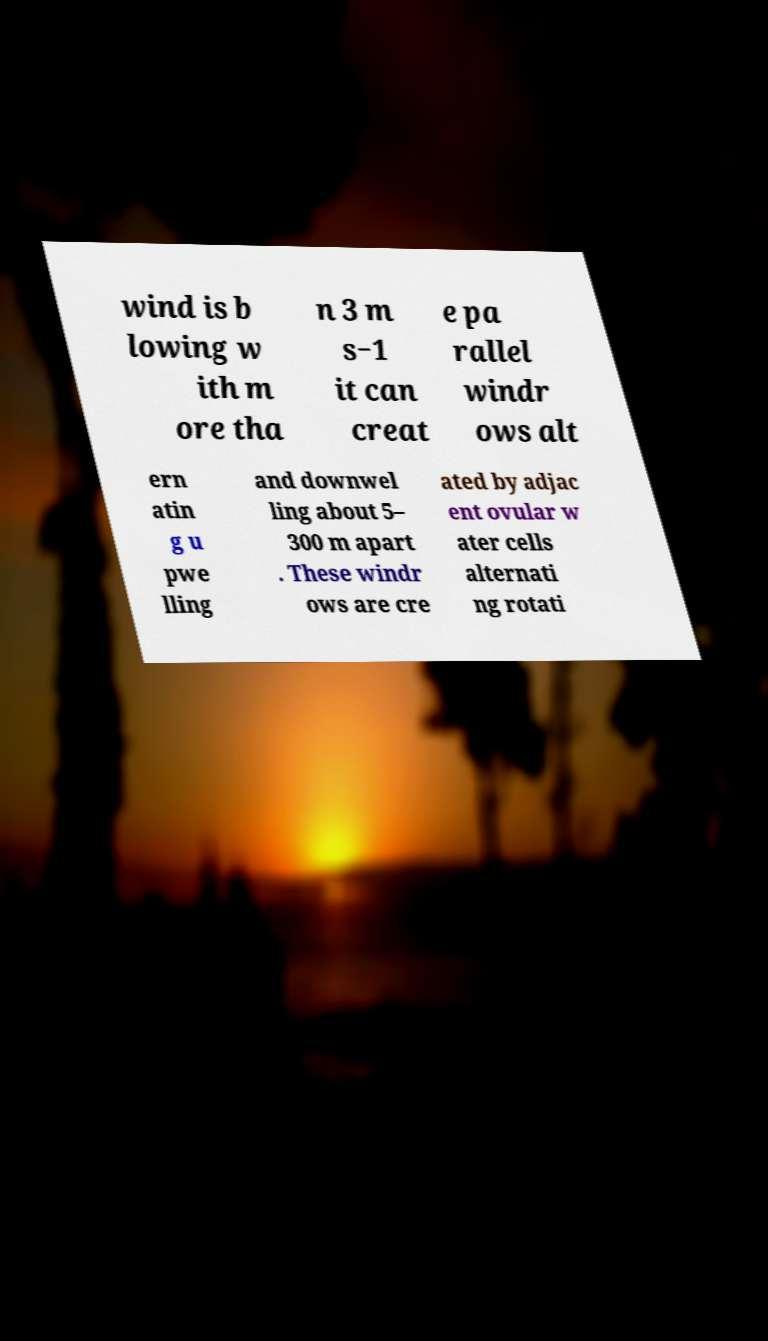Could you assist in decoding the text presented in this image and type it out clearly? wind is b lowing w ith m ore tha n 3 m s−1 it can creat e pa rallel windr ows alt ern atin g u pwe lling and downwel ling about 5– 300 m apart . These windr ows are cre ated by adjac ent ovular w ater cells alternati ng rotati 